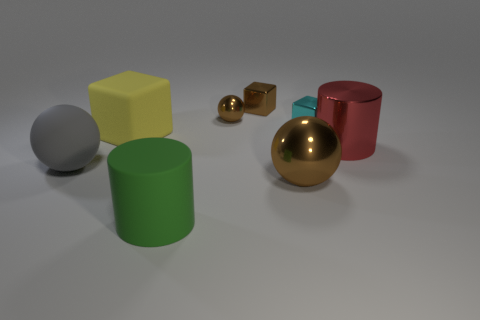Add 1 tiny brown metal cubes. How many objects exist? 9 Subtract all balls. How many objects are left? 5 Add 5 large green metallic cylinders. How many large green metallic cylinders exist? 5 Subtract 1 yellow cubes. How many objects are left? 7 Subtract all big purple shiny blocks. Subtract all shiny cubes. How many objects are left? 6 Add 8 cylinders. How many cylinders are left? 10 